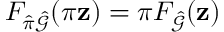Convert formula to latex. <formula><loc_0><loc_0><loc_500><loc_500>F _ { \hat { \pi } \hat { \mathcal { G } } } ( \pi z ) = \pi F _ { \hat { \mathcal { G } } } ( z )</formula> 